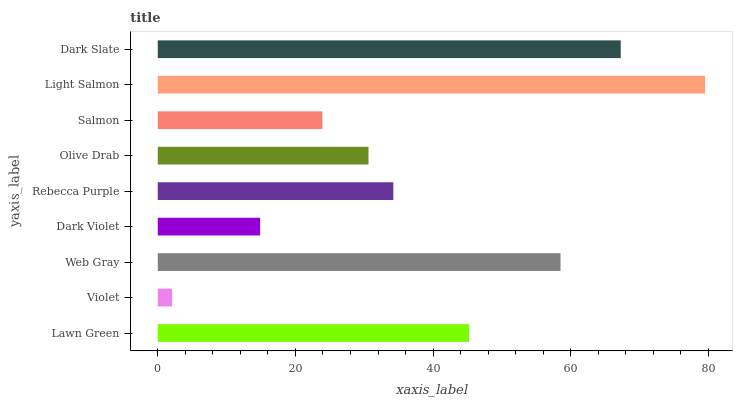Is Violet the minimum?
Answer yes or no. Yes. Is Light Salmon the maximum?
Answer yes or no. Yes. Is Web Gray the minimum?
Answer yes or no. No. Is Web Gray the maximum?
Answer yes or no. No. Is Web Gray greater than Violet?
Answer yes or no. Yes. Is Violet less than Web Gray?
Answer yes or no. Yes. Is Violet greater than Web Gray?
Answer yes or no. No. Is Web Gray less than Violet?
Answer yes or no. No. Is Rebecca Purple the high median?
Answer yes or no. Yes. Is Rebecca Purple the low median?
Answer yes or no. Yes. Is Salmon the high median?
Answer yes or no. No. Is Web Gray the low median?
Answer yes or no. No. 